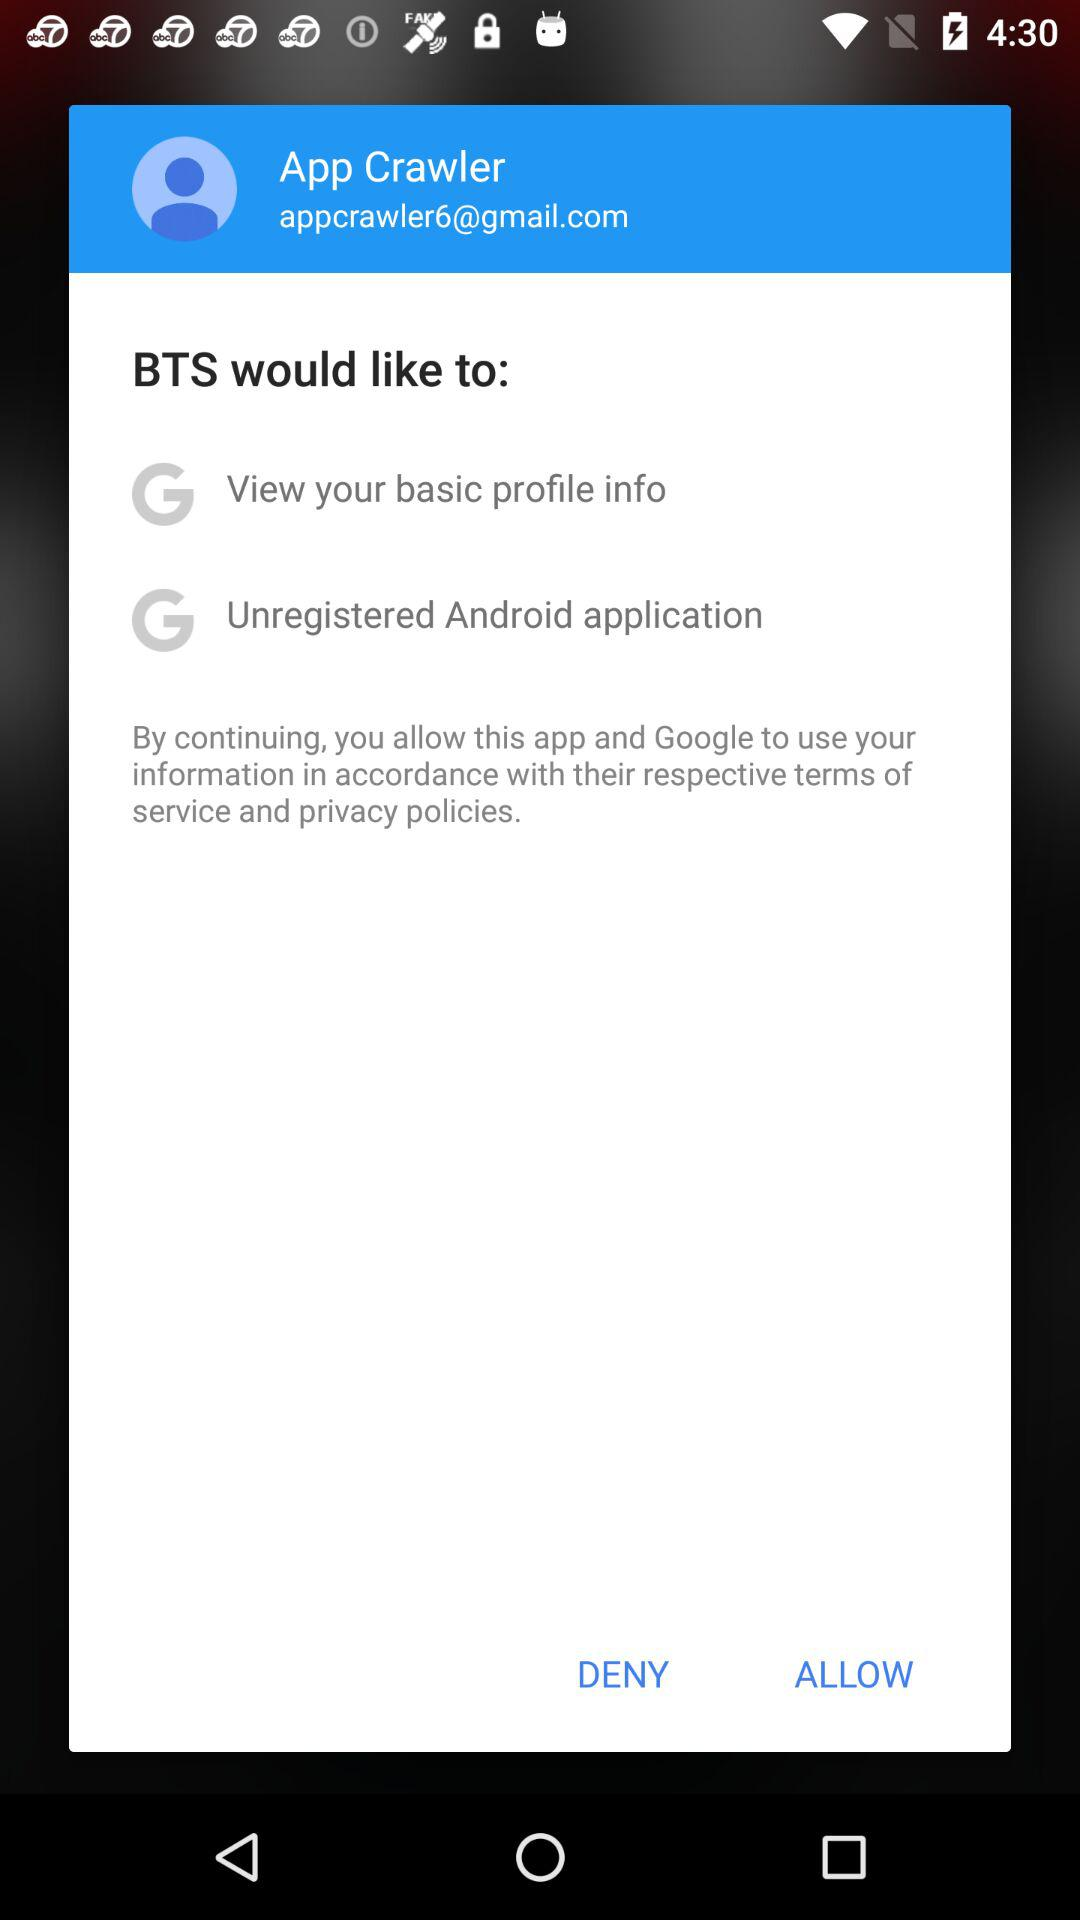How many permissions are BTS requesting?
Answer the question using a single word or phrase. 2 